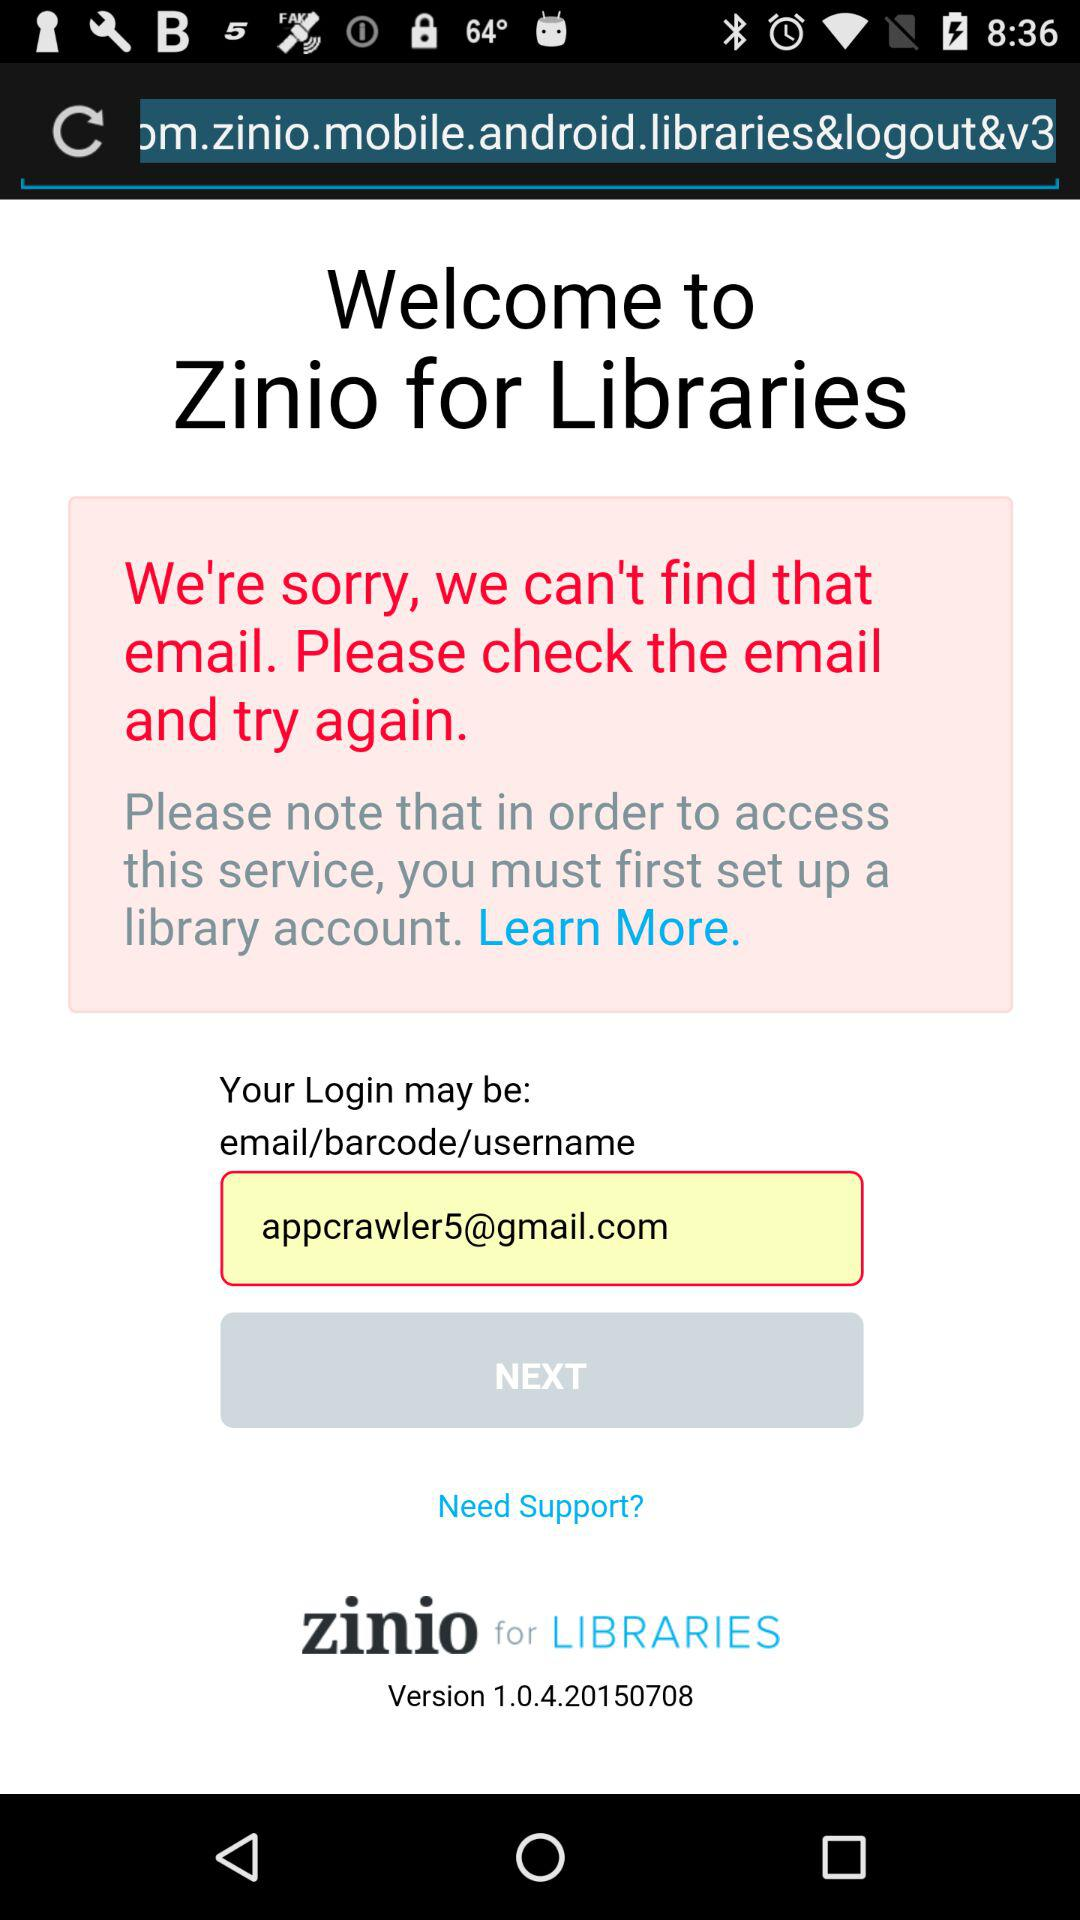What is the email address? The email address is appcrawler5@gmail.com. 